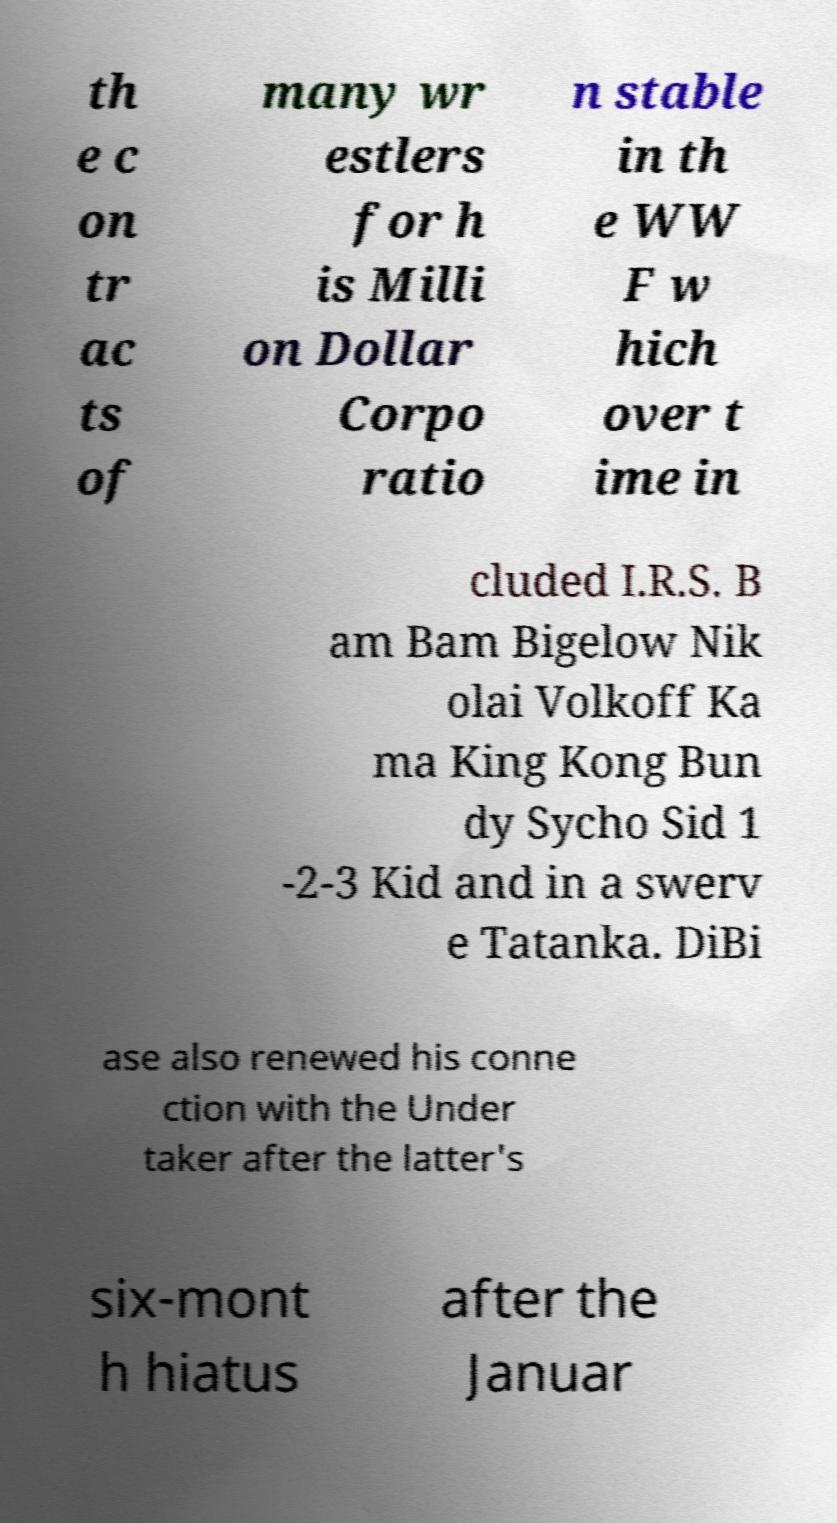Can you accurately transcribe the text from the provided image for me? th e c on tr ac ts of many wr estlers for h is Milli on Dollar Corpo ratio n stable in th e WW F w hich over t ime in cluded I.R.S. B am Bam Bigelow Nik olai Volkoff Ka ma King Kong Bun dy Sycho Sid 1 -2-3 Kid and in a swerv e Tatanka. DiBi ase also renewed his conne ction with the Under taker after the latter's six-mont h hiatus after the Januar 